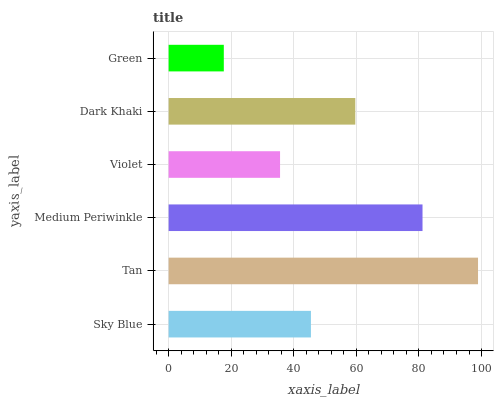Is Green the minimum?
Answer yes or no. Yes. Is Tan the maximum?
Answer yes or no. Yes. Is Medium Periwinkle the minimum?
Answer yes or no. No. Is Medium Periwinkle the maximum?
Answer yes or no. No. Is Tan greater than Medium Periwinkle?
Answer yes or no. Yes. Is Medium Periwinkle less than Tan?
Answer yes or no. Yes. Is Medium Periwinkle greater than Tan?
Answer yes or no. No. Is Tan less than Medium Periwinkle?
Answer yes or no. No. Is Dark Khaki the high median?
Answer yes or no. Yes. Is Sky Blue the low median?
Answer yes or no. Yes. Is Violet the high median?
Answer yes or no. No. Is Tan the low median?
Answer yes or no. No. 